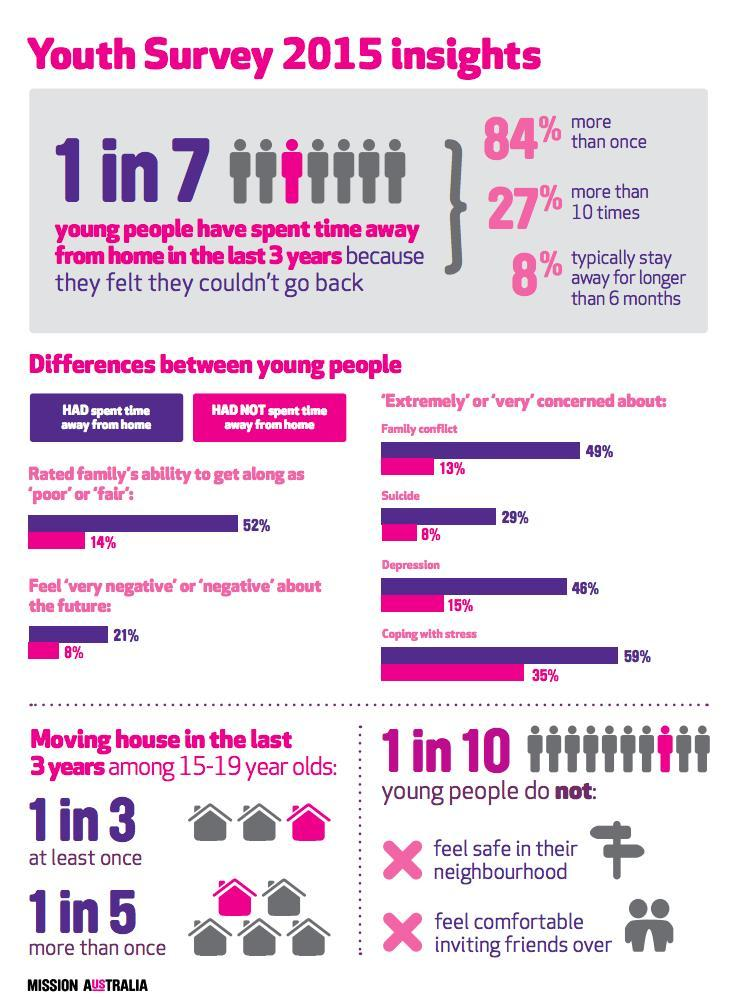who is more likely to feel negative about the future - youth who had spent time away from home or youth who had not spent time away from home
Answer the question with a short phrase. youth who had spent time away from home who is more likely to be concerned about family conflict - youth who had spent time away from home or youth who had not spent time away from home youth who had spent time away from home who is more likely to be concerned about depression - youth who had spent time away from home or youth who had not spent time away from home youth who had spent time away from home what percentage of young people do not feel safe in their neighborhood? 10 who is more likely to be concerned about suicide - youth who had spent time away from home or youth who had not spent time away from home youth who had spent time away from home 